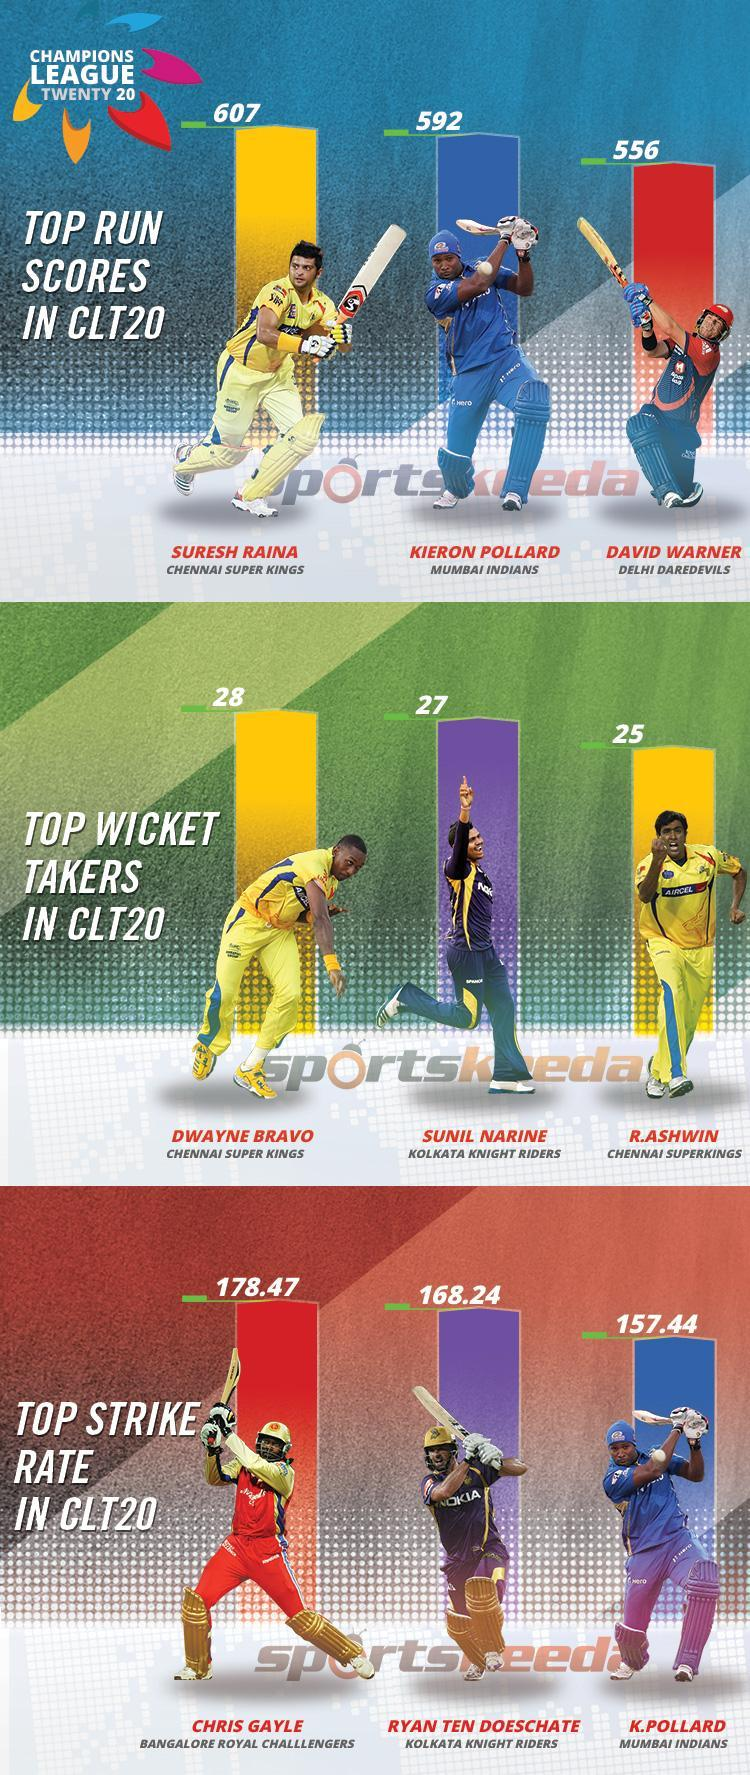Which CLT20 team does David Warner play for?
Answer the question with a short phrase. DELHI DAREDEVILS Which CLT20 team does Chris Gayle play for? BANGALORE ROYAL CHALLENGERS Who is the second highest wicket taker in CLT20 matches? SUNIL NARINE Which player has the top strike rate in CLT20? CHRIS GAYLE What is the strike rate of K. Pollard in CLT20? 157.44 What is the best score of Kieron Pollard in CLT20? 592 